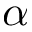Convert formula to latex. <formula><loc_0><loc_0><loc_500><loc_500>\alpha</formula> 